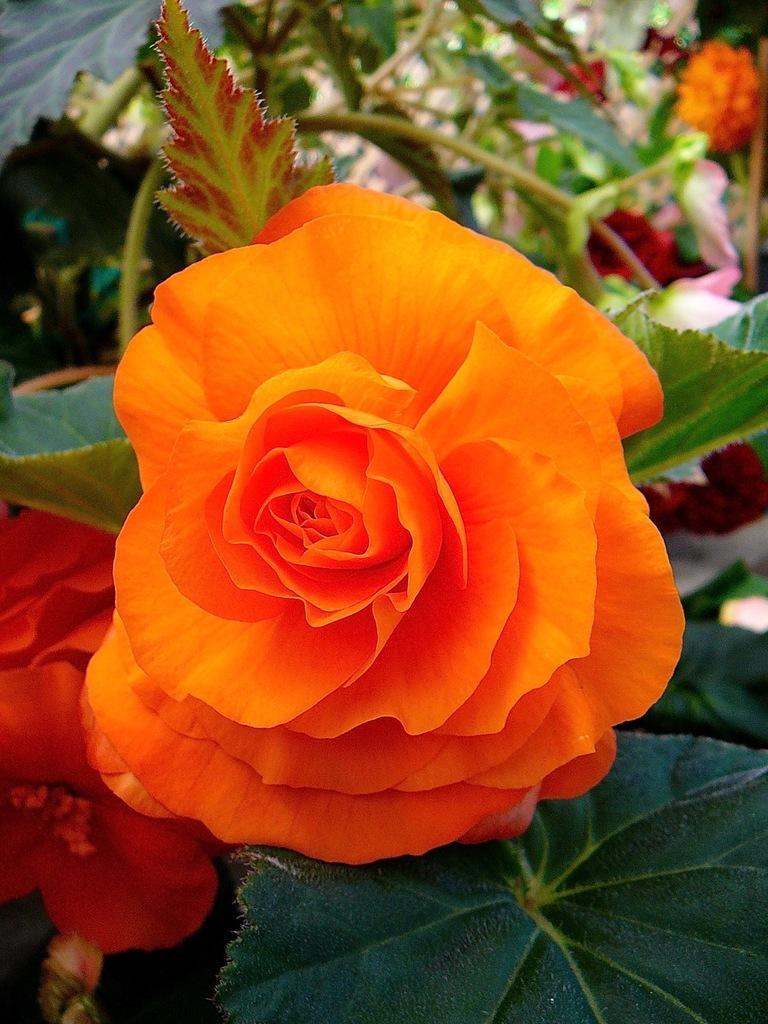Could you give a brief overview of what you see in this image? In this image we can see flower with some leaves. In the background, we can see some flowers on the plants. 